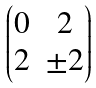Convert formula to latex. <formula><loc_0><loc_0><loc_500><loc_500>\begin{pmatrix} 0 & 2 \\ 2 & \pm 2 \end{pmatrix}</formula> 